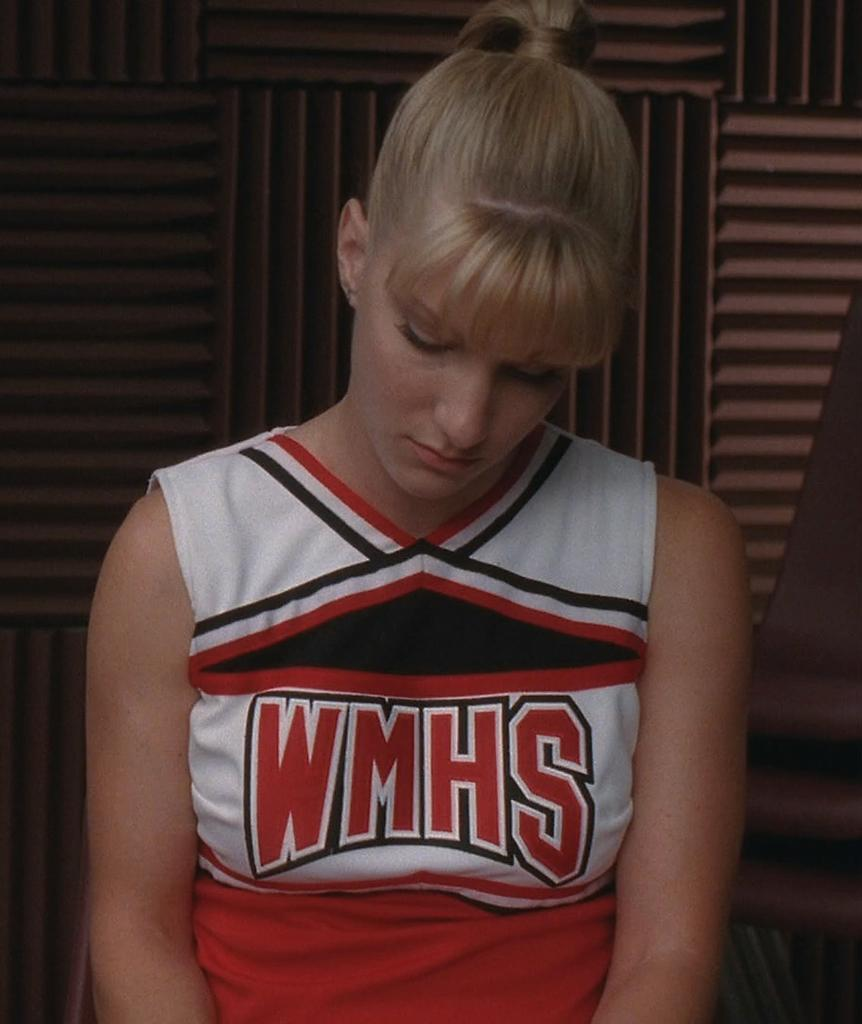<image>
Write a terse but informative summary of the picture. A blonde woman wearing a red and white cheerleading outfit with the text WMHS on her chest. 